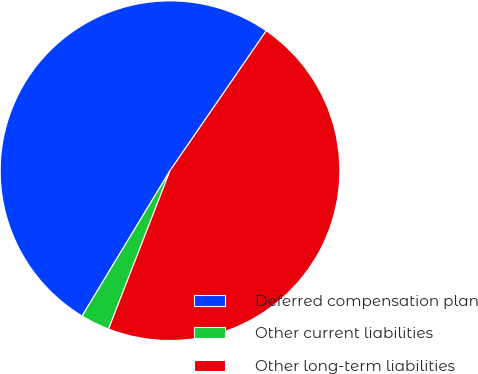Convert chart. <chart><loc_0><loc_0><loc_500><loc_500><pie_chart><fcel>Deferred compensation plan<fcel>Other current liabilities<fcel>Other long-term liabilities<nl><fcel>50.93%<fcel>2.77%<fcel>46.3%<nl></chart> 